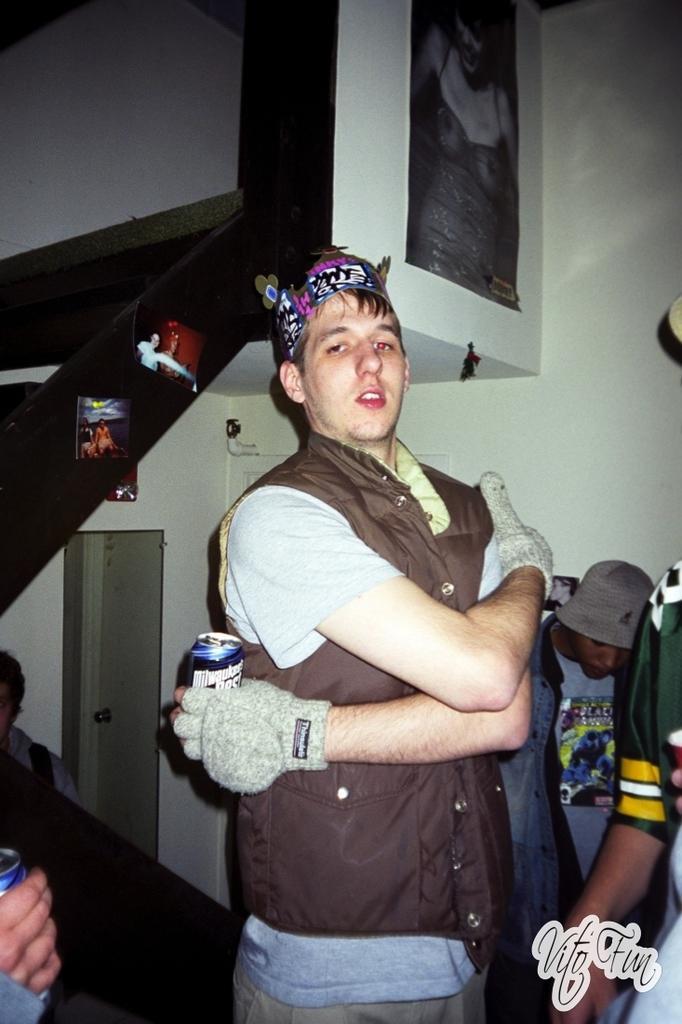Please provide a concise description of this image. In this picture we can see people and in the background we can see a wall and some objects, in the bottom right we can see some text. 